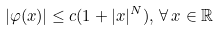Convert formula to latex. <formula><loc_0><loc_0><loc_500><loc_500>| \varphi ( x ) | \leq c ( 1 + | x | ^ { N } ) , \, \forall \, x \in \mathbb { R }</formula> 